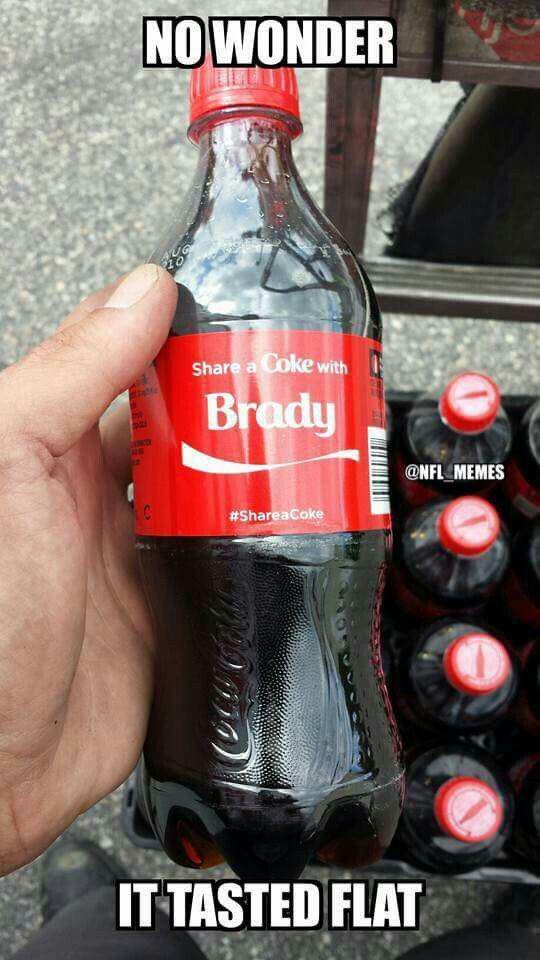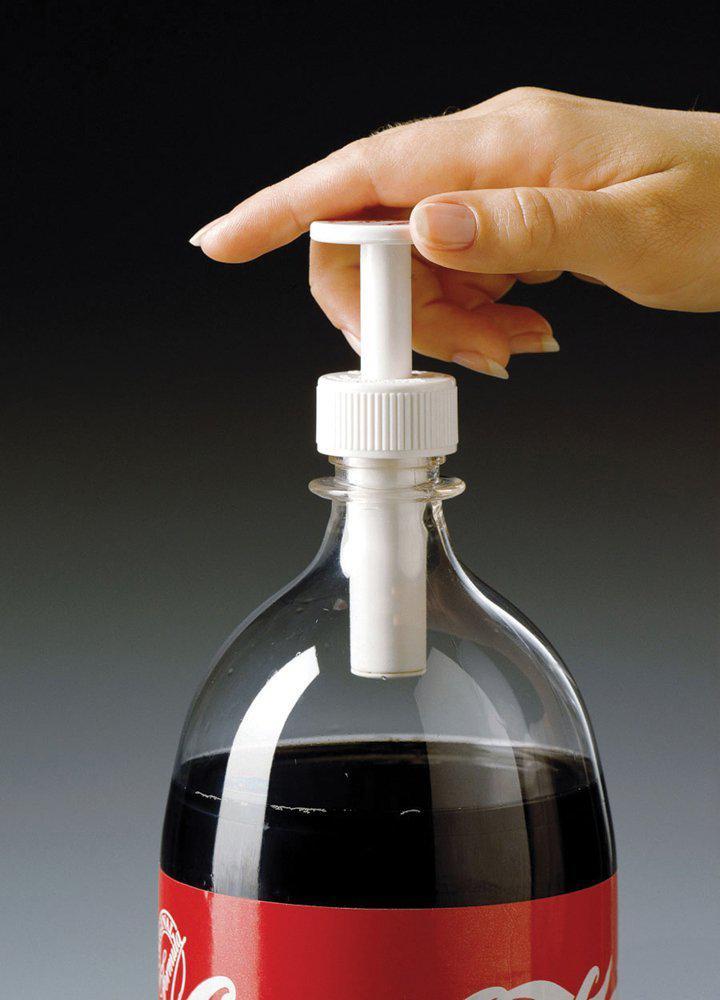The first image is the image on the left, the second image is the image on the right. Analyze the images presented: Is the assertion "One of the images contains a Pepsi product." valid? Answer yes or no. No. 